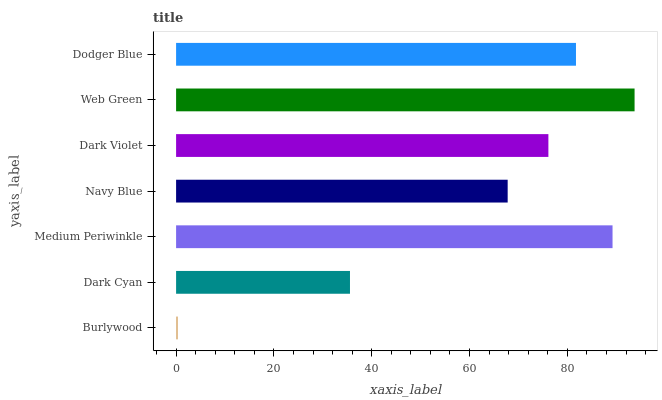Is Burlywood the minimum?
Answer yes or no. Yes. Is Web Green the maximum?
Answer yes or no. Yes. Is Dark Cyan the minimum?
Answer yes or no. No. Is Dark Cyan the maximum?
Answer yes or no. No. Is Dark Cyan greater than Burlywood?
Answer yes or no. Yes. Is Burlywood less than Dark Cyan?
Answer yes or no. Yes. Is Burlywood greater than Dark Cyan?
Answer yes or no. No. Is Dark Cyan less than Burlywood?
Answer yes or no. No. Is Dark Violet the high median?
Answer yes or no. Yes. Is Dark Violet the low median?
Answer yes or no. Yes. Is Web Green the high median?
Answer yes or no. No. Is Web Green the low median?
Answer yes or no. No. 